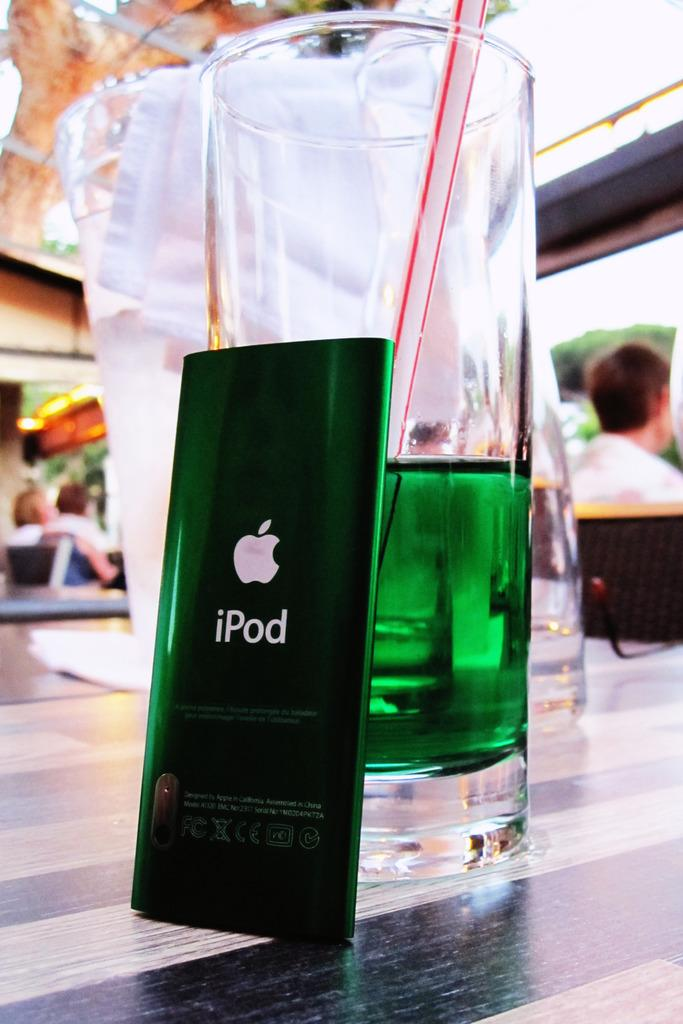<image>
Share a concise interpretation of the image provided. An iPod is sitting next to a glass with a green liquid in it. 